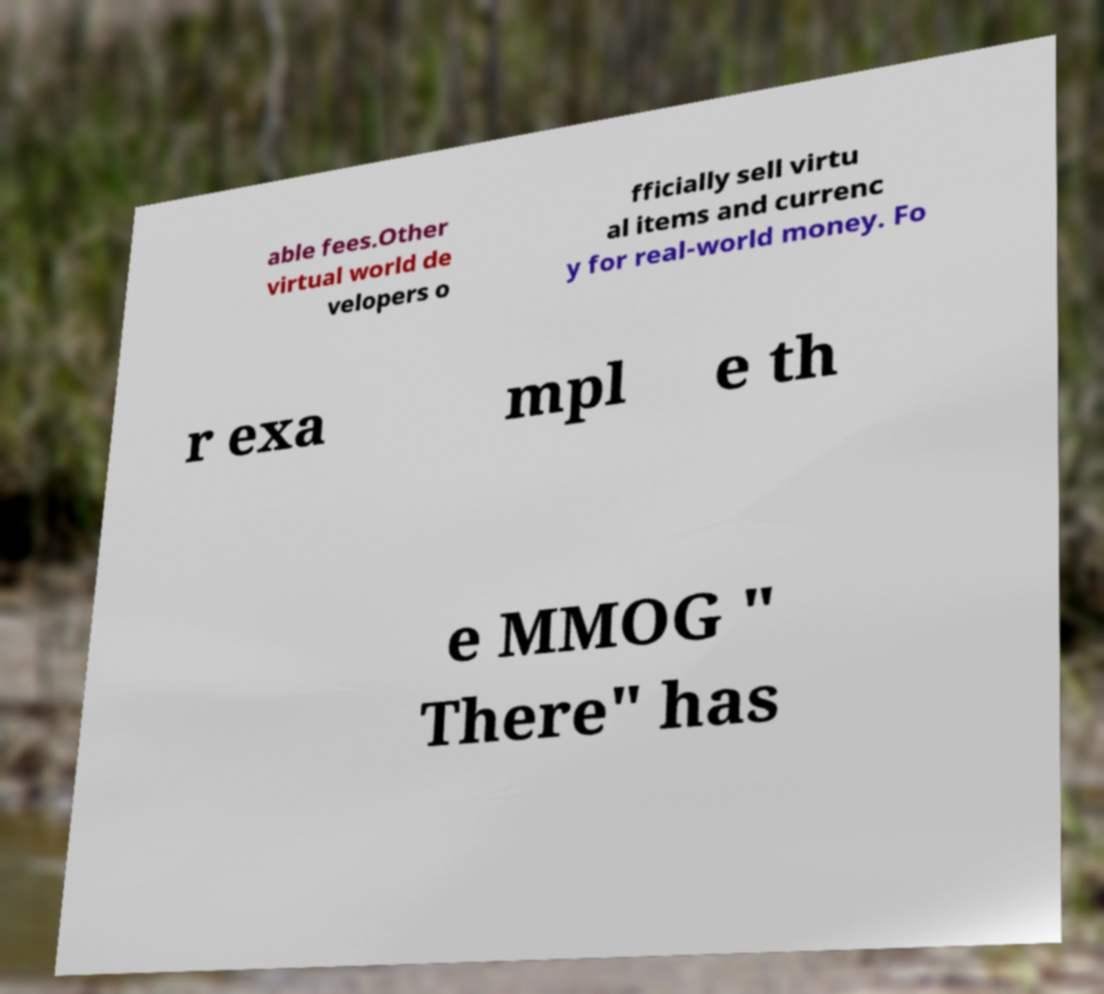Can you accurately transcribe the text from the provided image for me? able fees.Other virtual world de velopers o fficially sell virtu al items and currenc y for real-world money. Fo r exa mpl e th e MMOG " There" has 